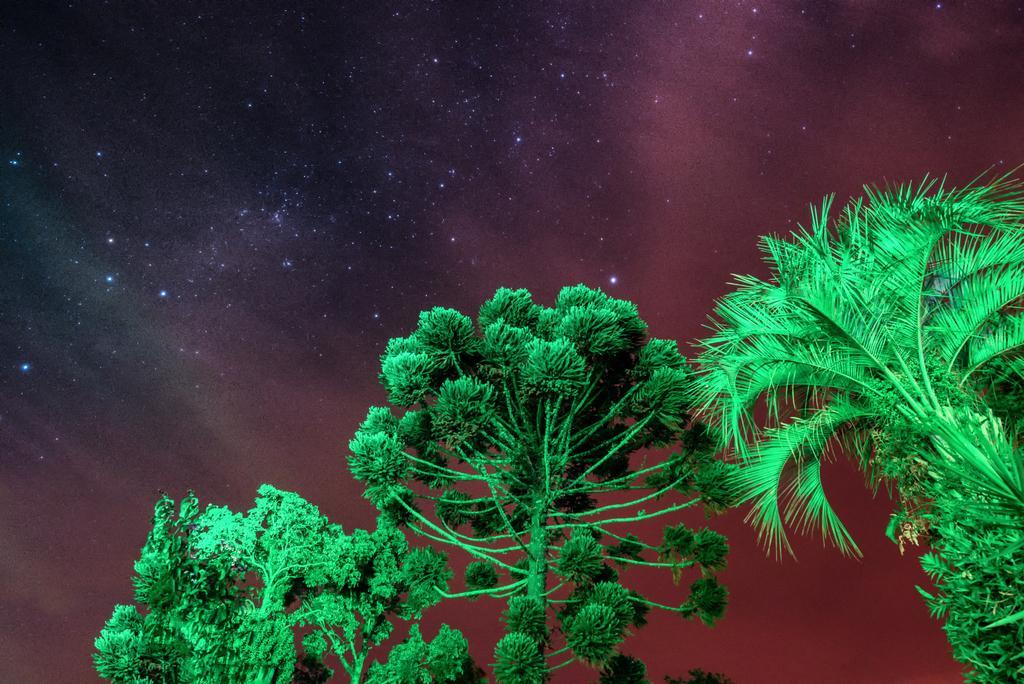In one or two sentences, can you explain what this image depicts? In this picture we can see the trees. In the background of the image we can see the stars are present in the sky. 